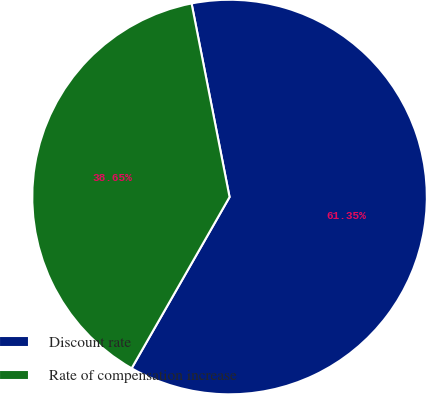Convert chart. <chart><loc_0><loc_0><loc_500><loc_500><pie_chart><fcel>Discount rate<fcel>Rate of compensation increase<nl><fcel>61.35%<fcel>38.65%<nl></chart> 